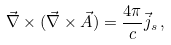Convert formula to latex. <formula><loc_0><loc_0><loc_500><loc_500>\vec { \nabla } \times ( \vec { \nabla } \times \vec { A } ) = \frac { 4 \pi } { c } \vec { j } _ { s } \, ,</formula> 